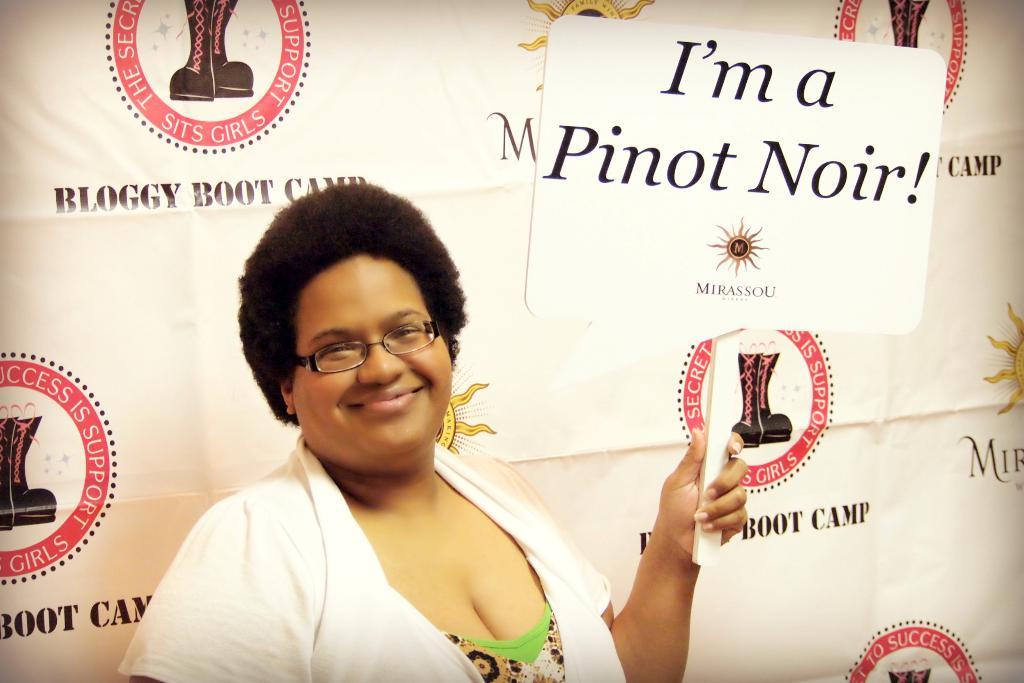Who is the main subject in the image? There is a lady in the center of the image. What is the lady doing in the image? The lady is standing and smiling. What is the lady wearing in the image? The lady is wearing a coat and spectacles. What is the lady holding in the image? The lady is holding a board. What can be seen in the background of the image? There is a banner in the background of the image. What type of banana is the lady eating in the image? There is no banana present in the image, and the lady is not eating anything. Is the lady driving a car in the image? There is no car or any indication of driving in the image. --- Facts: 1. There is a group of people in the image. 2. The people are wearing uniforms. 3. The people are holding musical instruments. 4. The background of the image is a stage. 5. There are microphones in the image. Absurd Topics: swimming, painting, mountain Conversation: How many people are in the image? There is a group of people in the image. What are the people wearing in the image? The people are wearing uniforms. What are the people holding in the image? The people are holding musical instruments. What can be seen in the background of the image? The background of the image is a stage. What might be used for amplifying sound in the image? There are microphones in the image. Reasoning: Let's think step by step in order to produce the conversation. We start by identifying the main subject in the image, which is the group of people. Then, we describe their clothing and what they are holding. Next, we mention the background element, which is the stage. Finally, we acknowledge the presence of microphones, which are used for amplifying sound. Each question is designed to elicit a specific detail about the image that is known from the provided facts. Absurd Question/Answer: Can you see any mountains in the background of the image? There are no mountains visible in the background of the image; it features a stage. What type of painting is the group of people creating in the image? There is no painting or any indication of painting in the image. 